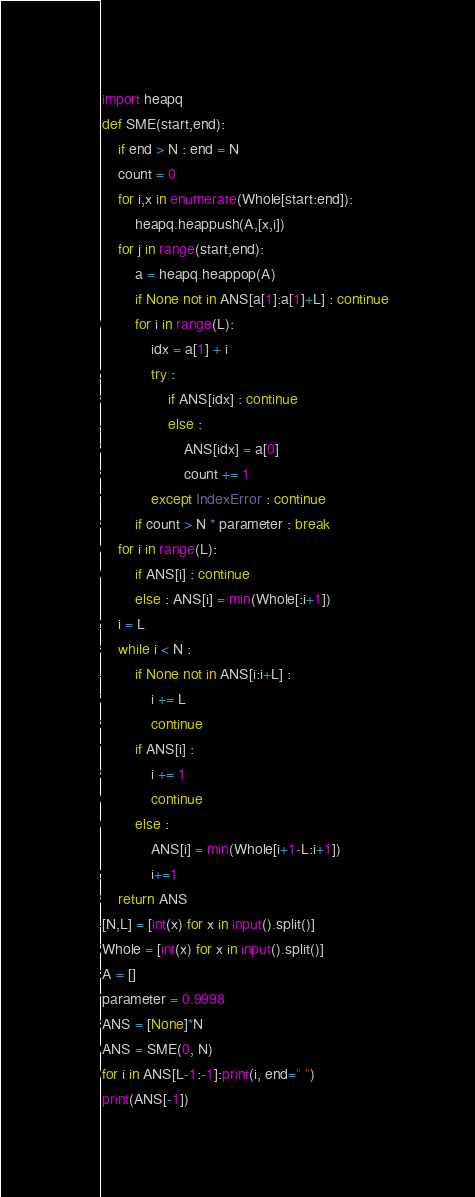<code> <loc_0><loc_0><loc_500><loc_500><_Python_>import heapq
def SME(start,end):
    if end > N : end = N
    count = 0
    for i,x in enumerate(Whole[start:end]):
        heapq.heappush(A,[x,i])
    for j in range(start,end):
        a = heapq.heappop(A)
        if None not in ANS[a[1]:a[1]+L] : continue
        for i in range(L):
            idx = a[1] + i
            try :
                if ANS[idx] : continue
                else :
                    ANS[idx] = a[0]
                    count += 1
            except IndexError : continue
        if count > N * parameter : break
    for i in range(L):
        if ANS[i] : continue
        else : ANS[i] = min(Whole[:i+1])
    i = L
    while i < N :
        if None not in ANS[i:i+L] :
            i += L
            continue
        if ANS[i] : 
            i += 1
            continue
        else : 
            ANS[i] = min(Whole[i+1-L:i+1])
            i+=1
    return ANS
[N,L] = [int(x) for x in input().split()]
Whole = [int(x) for x in input().split()]
A = []
parameter = 0.9998
ANS = [None]*N
ANS = SME(0, N)
for i in ANS[L-1:-1]:print(i, end=" ")
print(ANS[-1])</code> 